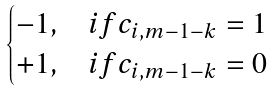Convert formula to latex. <formula><loc_0><loc_0><loc_500><loc_500>\begin{cases} - 1 , & i f c _ { i , m - 1 - k } = 1 \\ + 1 , & i f c _ { i , m - 1 - k } = 0 \end{cases}</formula> 